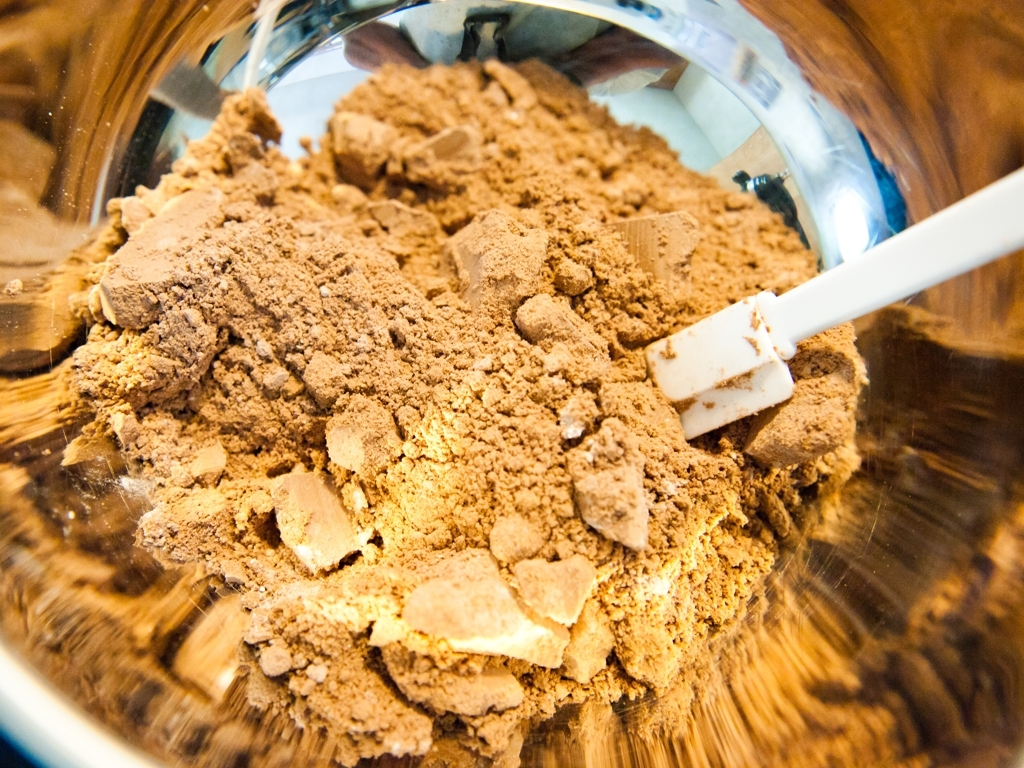What is the clarity of this photo? The clarity of the photo is actually quite high. Details such as the texture of the powder and the reflections in the surface show that the image is sharp and distinct, which indicates the camera was focused well, and the lighting conditions were adequate for capturing the scene without noticeable blur or noise. 